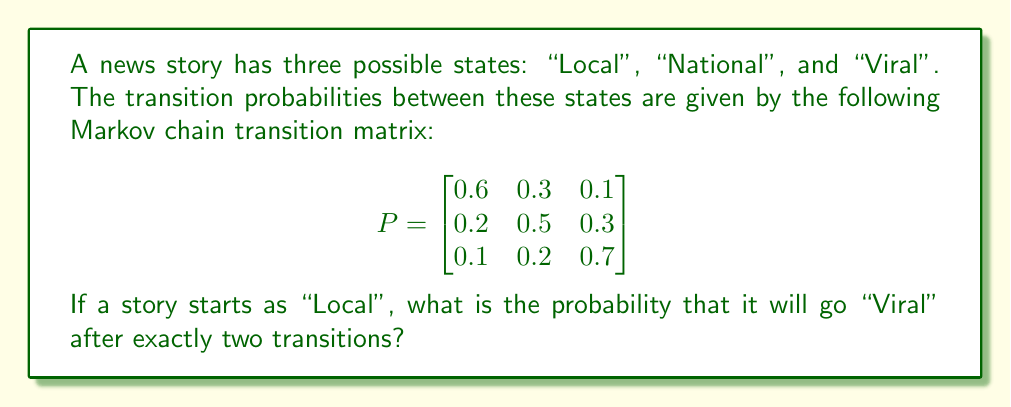Solve this math problem. To solve this problem, we need to use the Chapman-Kolmogorov equations and matrix multiplication:

1. Let's denote the initial state vector as $\pi_0 = [1, 0, 0]$, since the story starts as "Local".

2. We need to calculate $\pi_0 P^2$, where $P^2$ is the transition matrix raised to the power of 2.

3. First, let's calculate $P^2$:

   $$
   P^2 = \begin{bmatrix}
   0.6 & 0.3 & 0.1 \\
   0.2 & 0.5 & 0.3 \\
   0.1 & 0.2 & 0.7
   \end{bmatrix} \times 
   \begin{bmatrix}
   0.6 & 0.3 & 0.1 \\
   0.2 & 0.5 & 0.3 \\
   0.1 & 0.2 & 0.7
   \end{bmatrix}
   $$

4. Performing the matrix multiplication:

   $$
   P^2 = \begin{bmatrix}
   0.43 & 0.36 & 0.21 \\
   0.29 & 0.40 & 0.31 \\
   0.22 & 0.31 & 0.47
   \end{bmatrix}
   $$

5. Now, we need to multiply $\pi_0$ by $P^2$:

   $$
   \pi_0 P^2 = [1, 0, 0] \times 
   \begin{bmatrix}
   0.43 & 0.36 & 0.21 \\
   0.29 & 0.40 & 0.31 \\
   0.22 & 0.31 & 0.47
   \end{bmatrix}
   $$

6. This multiplication gives us:

   $$
   \pi_0 P^2 = [0.43, 0.36, 0.21]
   $$

7. The probability of the story going "Viral" after exactly two transitions is the third element of this vector, which is 0.21 or 21%.
Answer: 0.21 